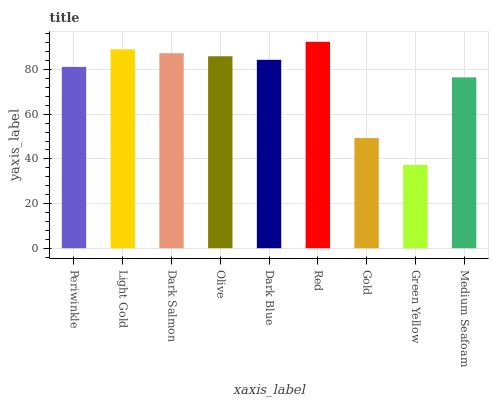Is Green Yellow the minimum?
Answer yes or no. Yes. Is Red the maximum?
Answer yes or no. Yes. Is Light Gold the minimum?
Answer yes or no. No. Is Light Gold the maximum?
Answer yes or no. No. Is Light Gold greater than Periwinkle?
Answer yes or no. Yes. Is Periwinkle less than Light Gold?
Answer yes or no. Yes. Is Periwinkle greater than Light Gold?
Answer yes or no. No. Is Light Gold less than Periwinkle?
Answer yes or no. No. Is Dark Blue the high median?
Answer yes or no. Yes. Is Dark Blue the low median?
Answer yes or no. Yes. Is Olive the high median?
Answer yes or no. No. Is Red the low median?
Answer yes or no. No. 